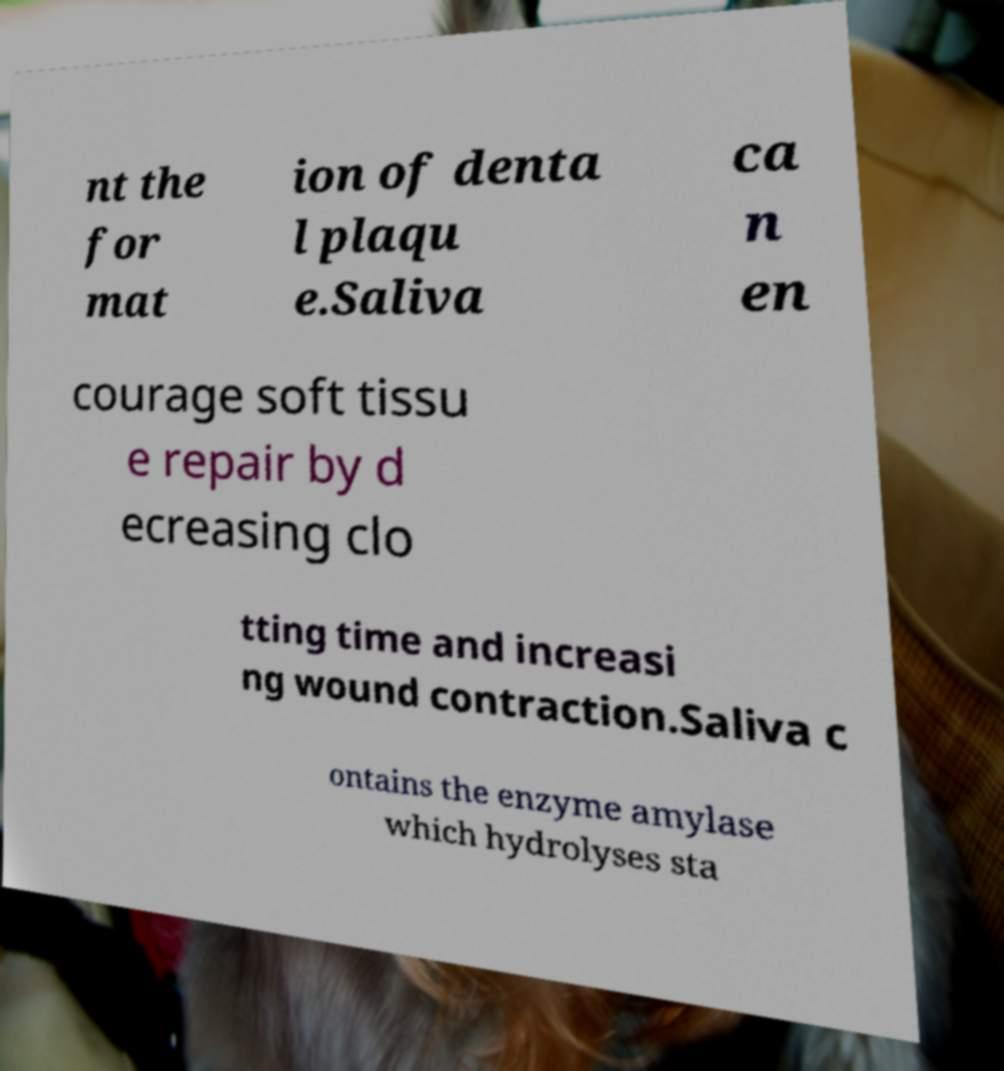I need the written content from this picture converted into text. Can you do that? nt the for mat ion of denta l plaqu e.Saliva ca n en courage soft tissu e repair by d ecreasing clo tting time and increasi ng wound contraction.Saliva c ontains the enzyme amylase which hydrolyses sta 